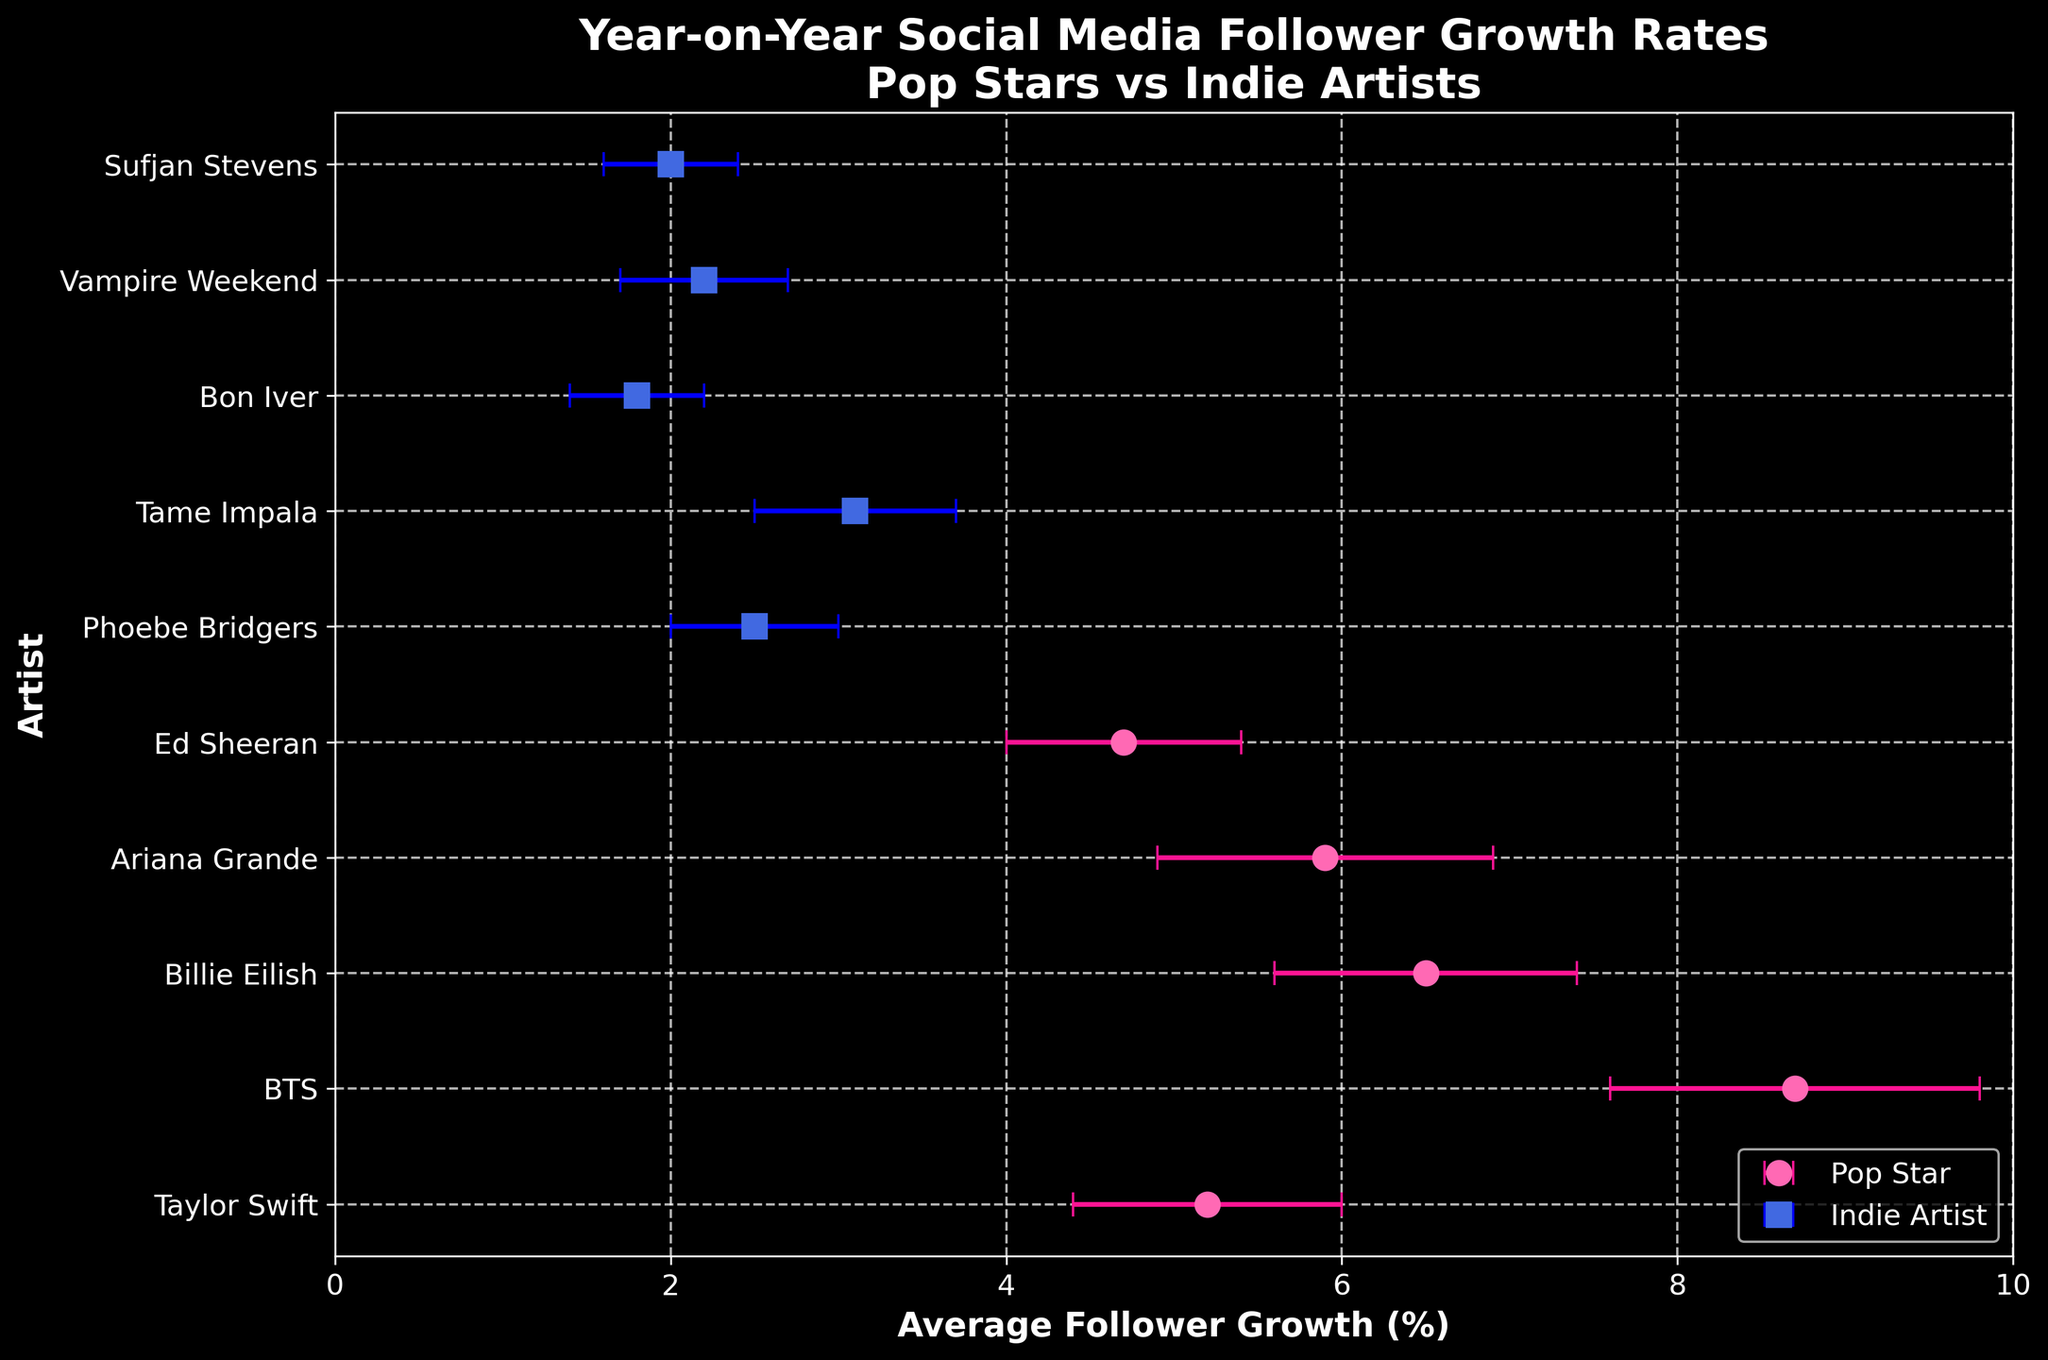What is the title of the plot? The title is generally at the top of the plot and summarizes what the plot depicts.
Answer: Year-on-Year Social Media Follower Growth Rates Pop Stars vs Indie Artists What is the average follower growth rate for BTS? Look for the dot corresponding to BTS in the plot and read the value on the x-axis directly.
Answer: 8.7 Which pop star has the lowest average follower growth rate? Identify all the pop stars in the plot, compare their values, and find the smallest one.
Answer: Ed Sheeran How many indie artists are depicted in the plot? Count the number of distinctive markers labeled as indie artists on the y-axis.
Answer: 5 Compare the average follower growth rates of Billie Eilish and Tame Impala. Who has a higher growth rate? Locate the dots for Billie Eilish and Tame Impala and compare their positions on the x-axis. Billie Eilish's dot is further right compared to Tame Impala.
Answer: Billie Eilish What is the range of average follower growth rates for pop stars? Identify the highest and lowest average follower growth rates among pop stars and calculate the difference. Maximum value is 8.7 (BTS) and minimum value is 4.7 (Ed Sheeran). The range is 8.7 - 4.7.
Answer: 4.0 What is the average follower growth rate for indie artists? Add up all the average growth rates for indie artists and divide by the number of indie artists. Average = (2.5 + 3.1 + 1.8 + 2.2 + 2.0) / 5.
Answer: 2.32 Who has a wider variability in follower growth rates, Taylor Swift or Bon Iver? Compare the error bars for Taylor Swift and Bon Iver. The longer error bar indicates higher variability. Taylor Swift has a standard deviation of 0.8, and Bon Iver has 0.4.
Answer: Taylor Swift If you were to consider only the average follower growth rates, do pop stars generally have higher growth rates than indie artists? Compare the average follower growth rates of the pop stars with the indie artists. Pop stars range from 4.7 to 8.7 while indie artists range from 1.8 to 3.1.
Answer: Yes 